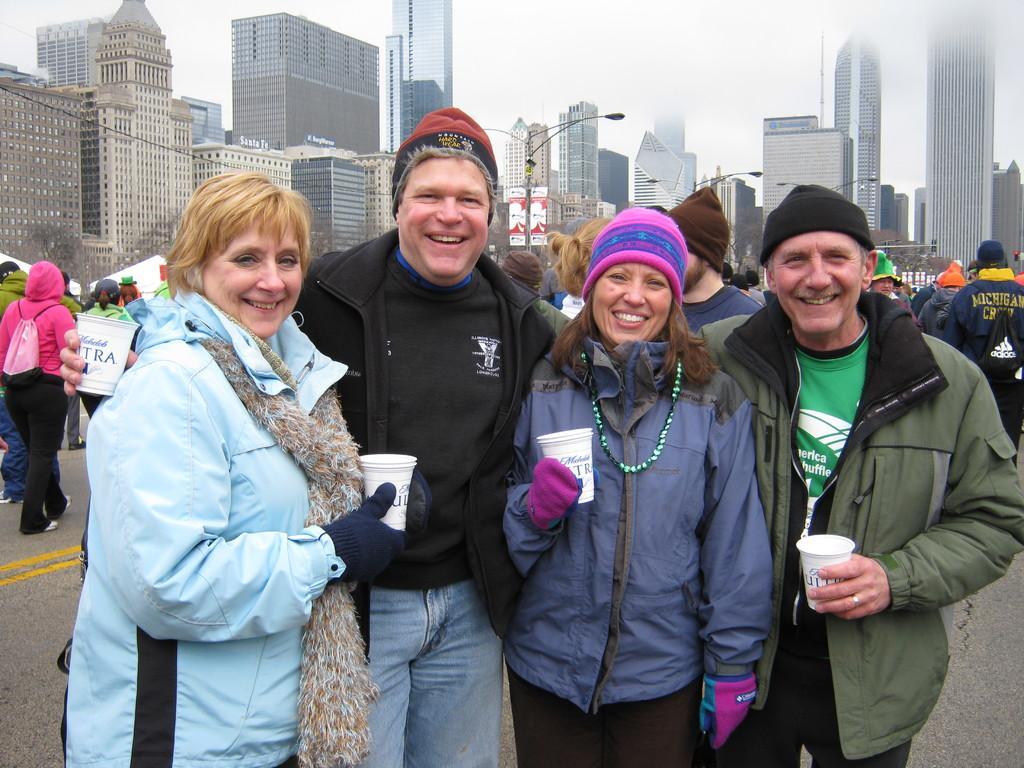Can you describe this image briefly? There are people standing in the foreground area of the image, there are people holding posters, buildings and the sky in the background. 